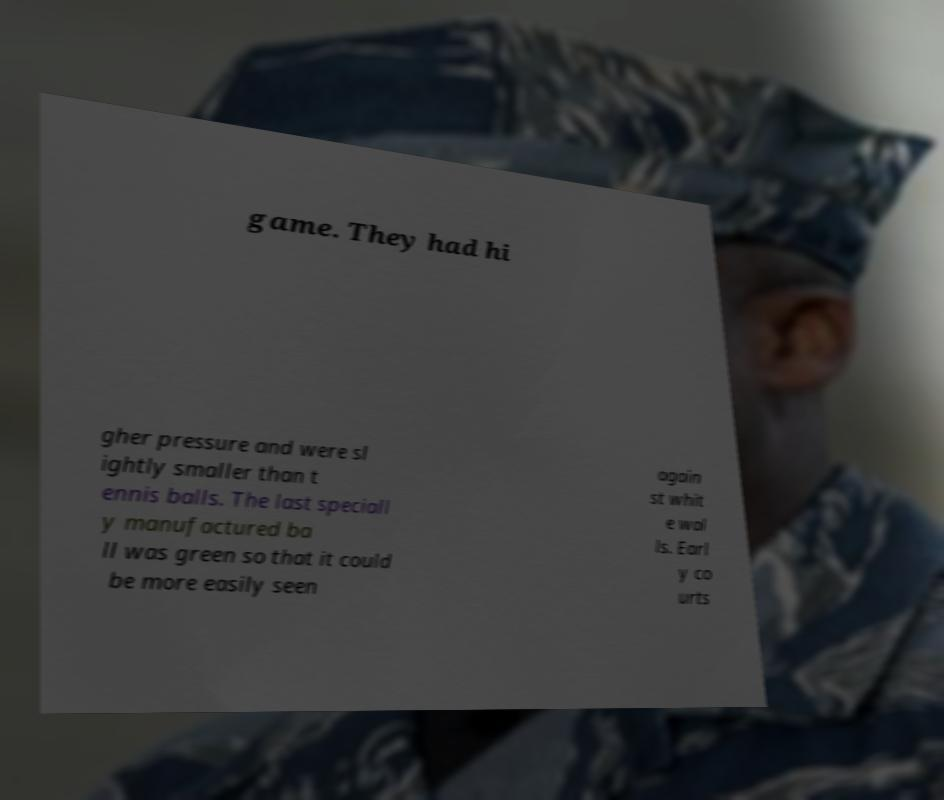There's text embedded in this image that I need extracted. Can you transcribe it verbatim? game. They had hi gher pressure and were sl ightly smaller than t ennis balls. The last speciall y manufactured ba ll was green so that it could be more easily seen again st whit e wal ls. Earl y co urts 